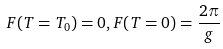Convert formula to latex. <formula><loc_0><loc_0><loc_500><loc_500>F ( T = T _ { 0 } ) = 0 , F ( T = 0 ) = \frac { 2 \pi } { g }</formula> 